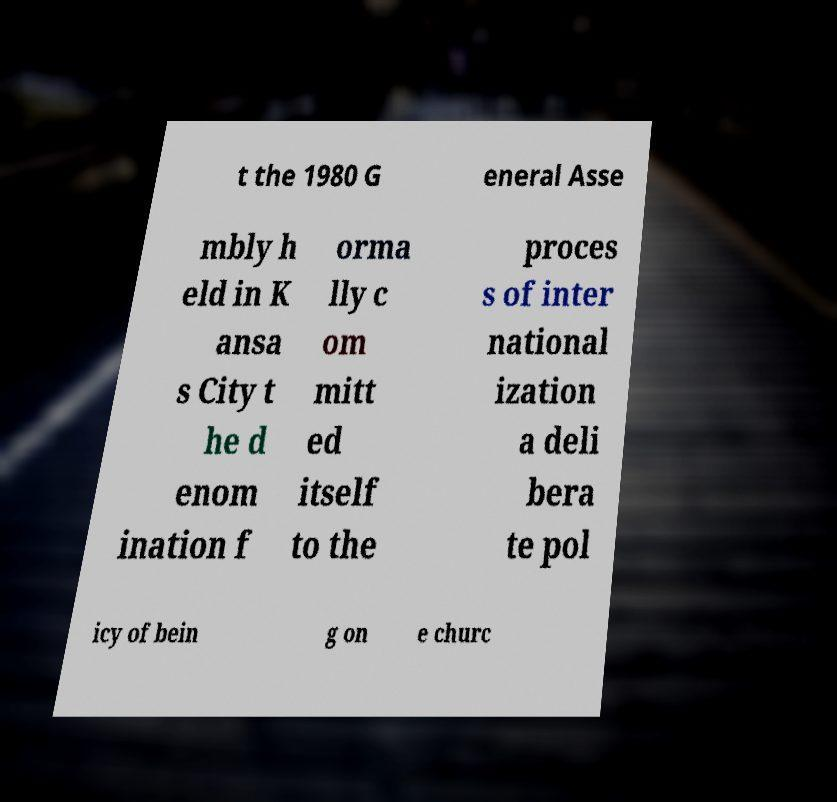Can you read and provide the text displayed in the image?This photo seems to have some interesting text. Can you extract and type it out for me? t the 1980 G eneral Asse mbly h eld in K ansa s City t he d enom ination f orma lly c om mitt ed itself to the proces s of inter national ization a deli bera te pol icy of bein g on e churc 